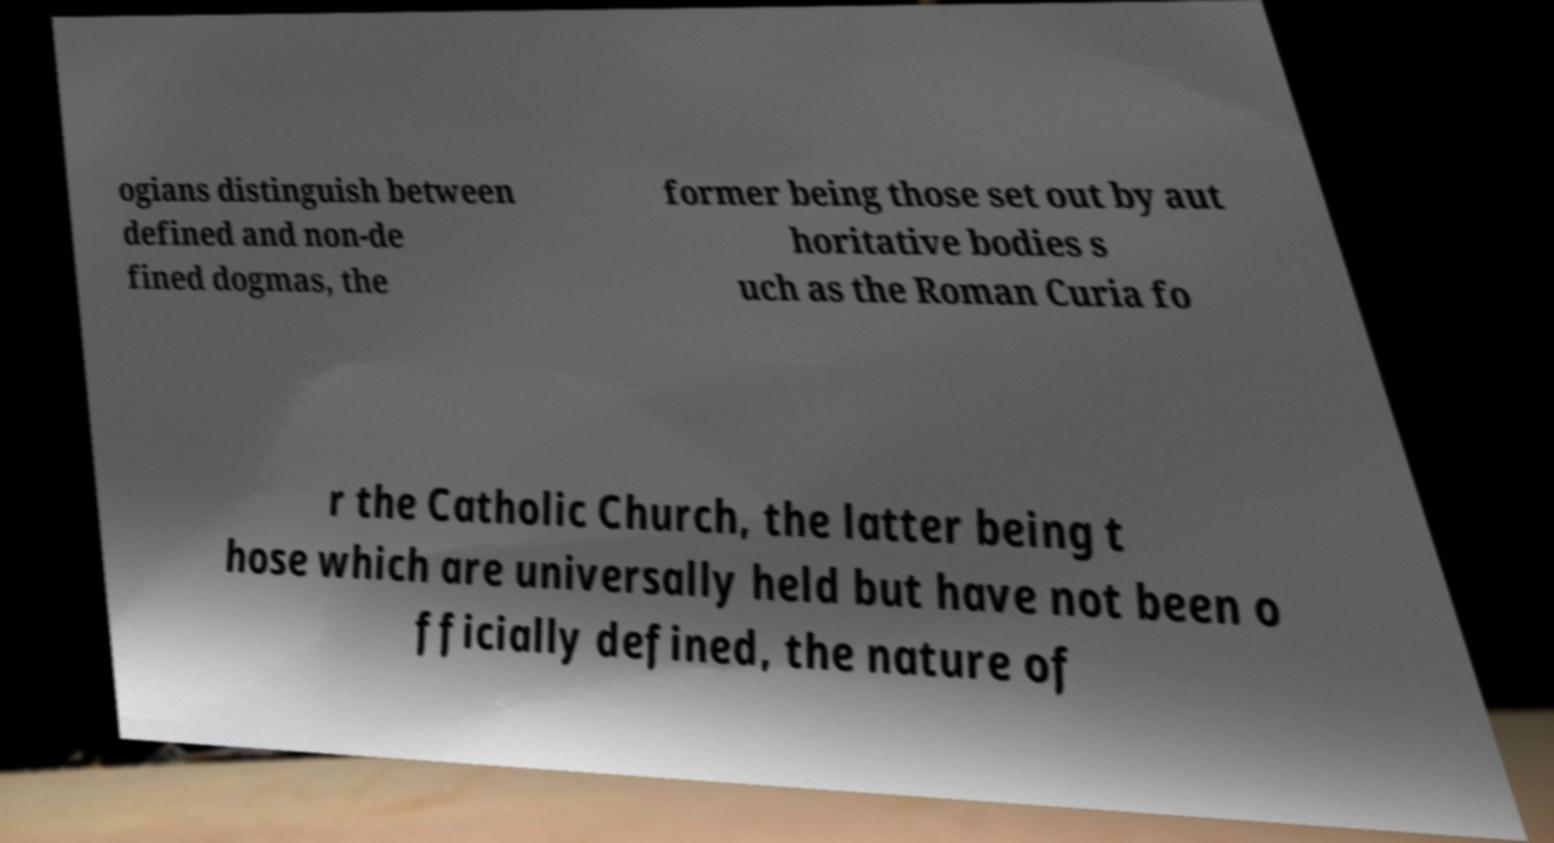There's text embedded in this image that I need extracted. Can you transcribe it verbatim? ogians distinguish between defined and non-de fined dogmas, the former being those set out by aut horitative bodies s uch as the Roman Curia fo r the Catholic Church, the latter being t hose which are universally held but have not been o fficially defined, the nature of 